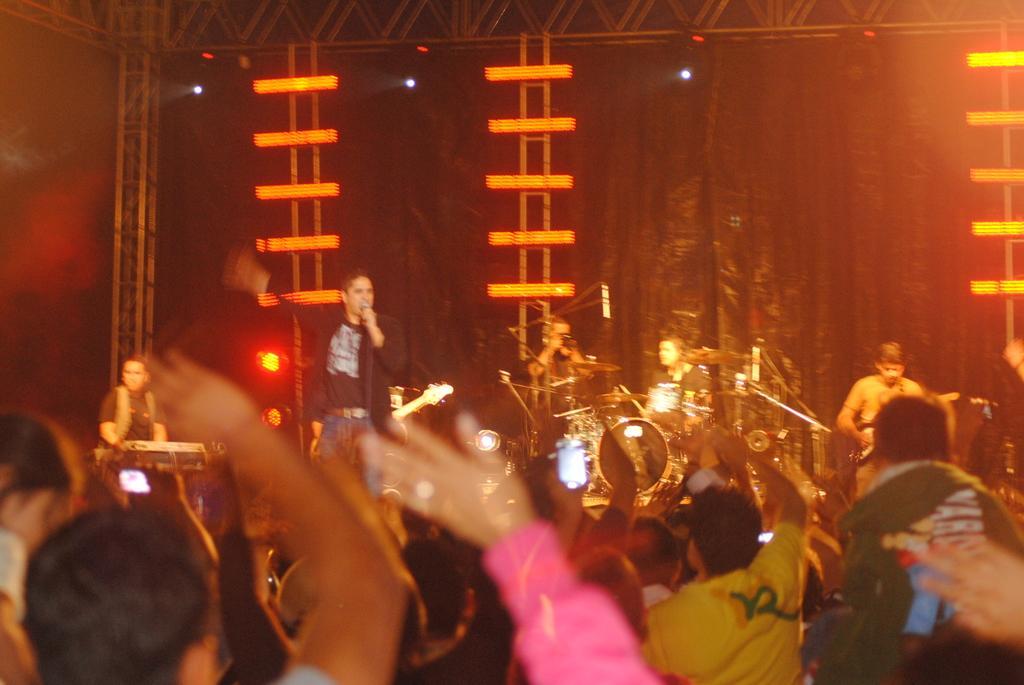Could you give a brief overview of what you see in this image? In this image there is a man standing and singing a song in the microphone , and at the back ground there are ,2 persons standing and playing drums ,another man standing and playing guitar, another man standing and playing a piano and there are focus lights and group of people standing. 